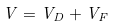<formula> <loc_0><loc_0><loc_500><loc_500>V = V _ { D } + V _ { F }</formula> 